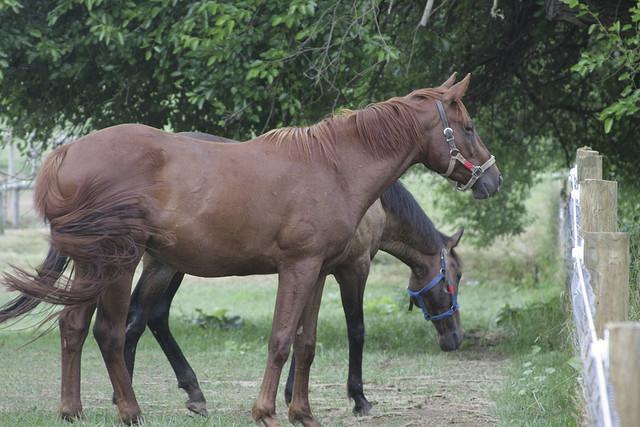How many horses are there?
Give a very brief answer. 2. How many white feet does this horse have?
Give a very brief answer. 0. How many horses are in the picture?
Give a very brief answer. 2. 